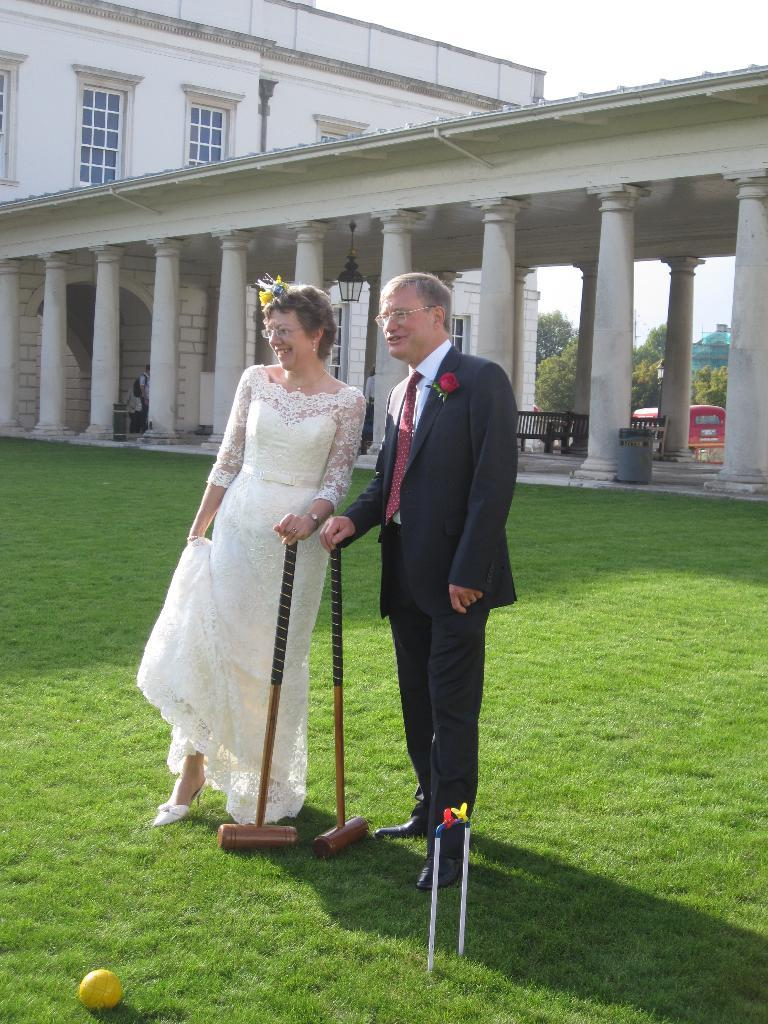What is the man in the image wearing? The man is wearing a black coat and black trousers. What is the woman in the image wearing? The woman is wearing a white dress. What can be seen in the background of the image? There is a building in the image. What type of produce is the man carrying in a bag during the week in the image? There is no produce or bag present in the image, and the concept of a week is not relevant to the image. 